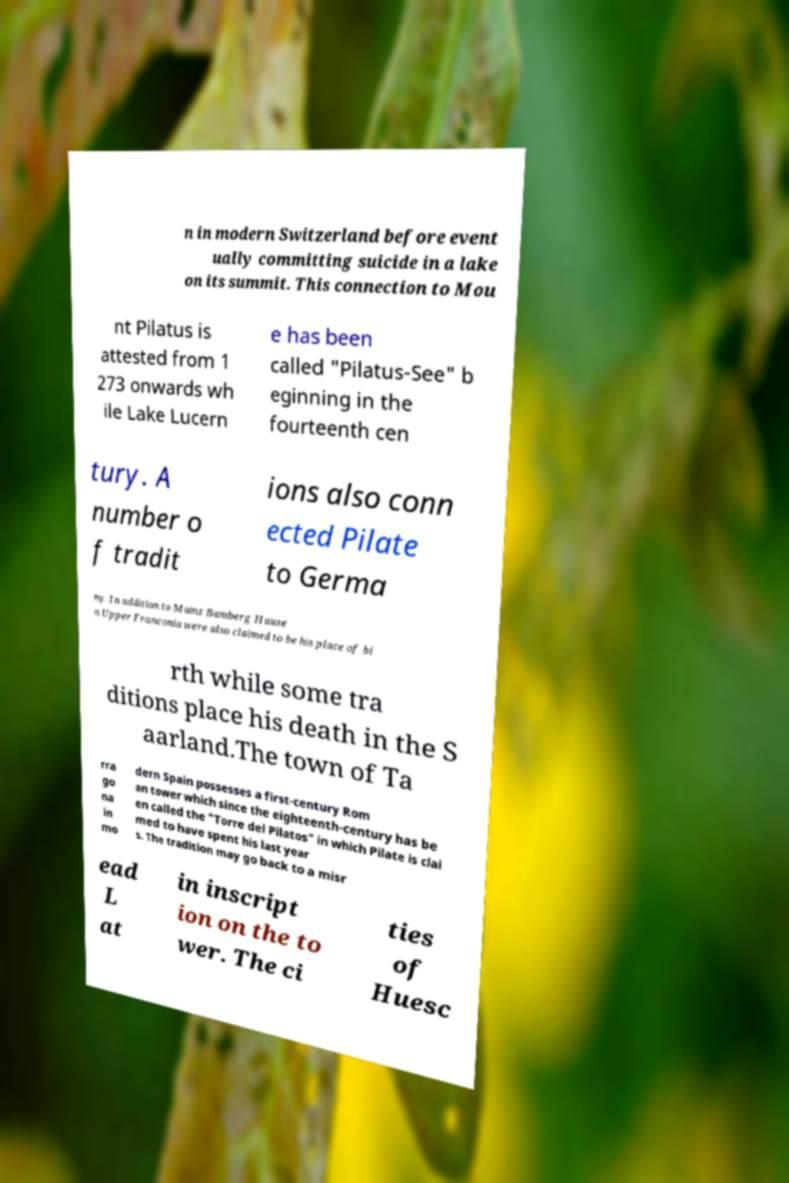Can you read and provide the text displayed in the image?This photo seems to have some interesting text. Can you extract and type it out for me? n in modern Switzerland before event ually committing suicide in a lake on its summit. This connection to Mou nt Pilatus is attested from 1 273 onwards wh ile Lake Lucern e has been called "Pilatus-See" b eginning in the fourteenth cen tury. A number o f tradit ions also conn ected Pilate to Germa ny. In addition to Mainz Bamberg Hause n Upper Franconia were also claimed to be his place of bi rth while some tra ditions place his death in the S aarland.The town of Ta rra go na in mo dern Spain possesses a first-century Rom an tower which since the eighteenth-century has be en called the "Torre del Pilatos" in which Pilate is clai med to have spent his last year s. The tradition may go back to a misr ead L at in inscript ion on the to wer. The ci ties of Huesc 